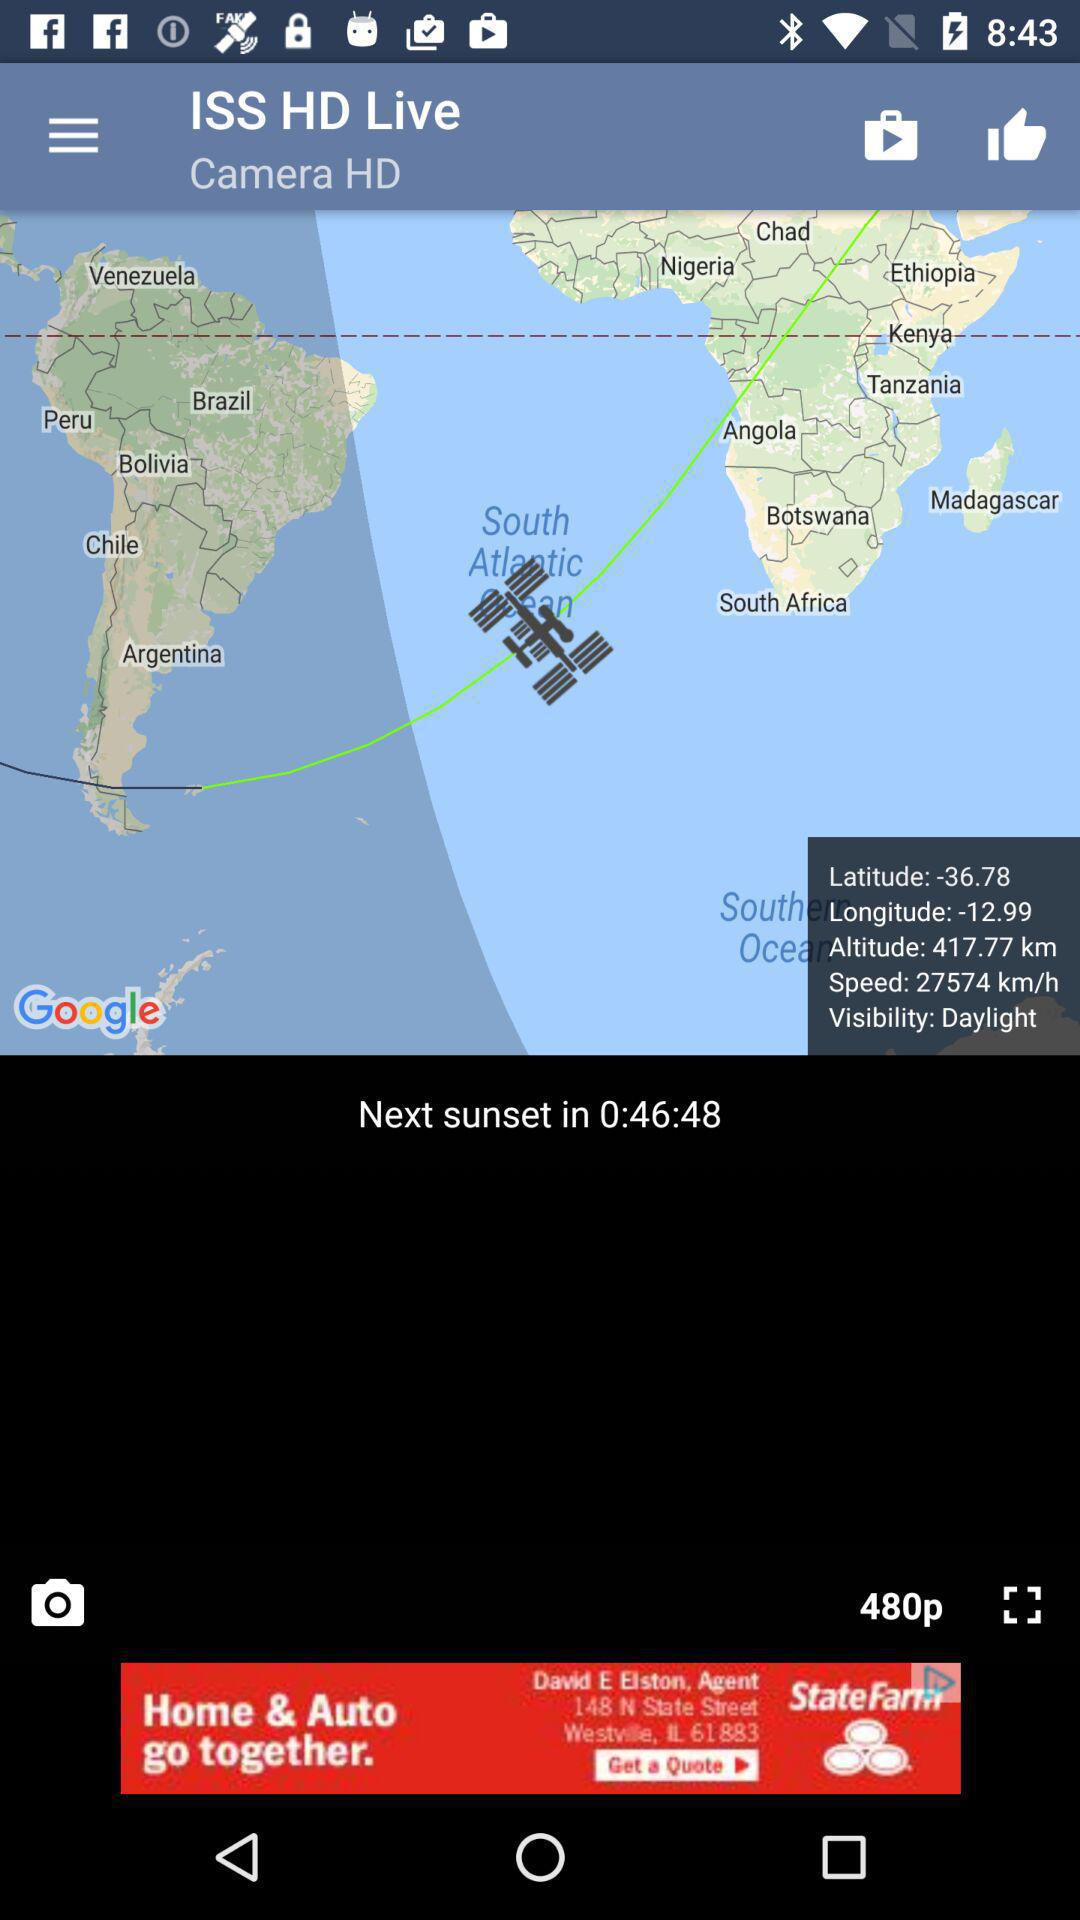What's the altitude? The altitude is 417.77 km. 